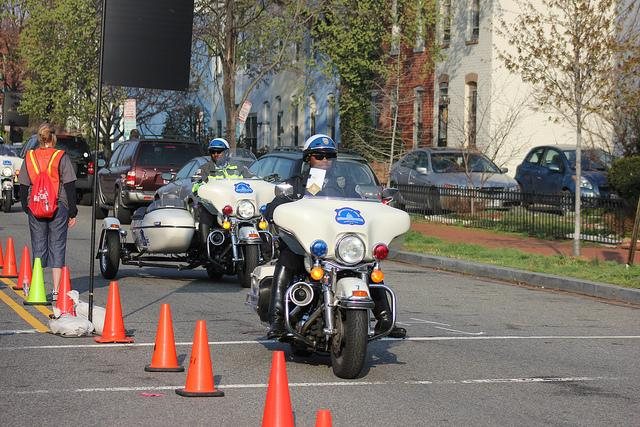What is the use of the following traffic cones? indoor hazards 